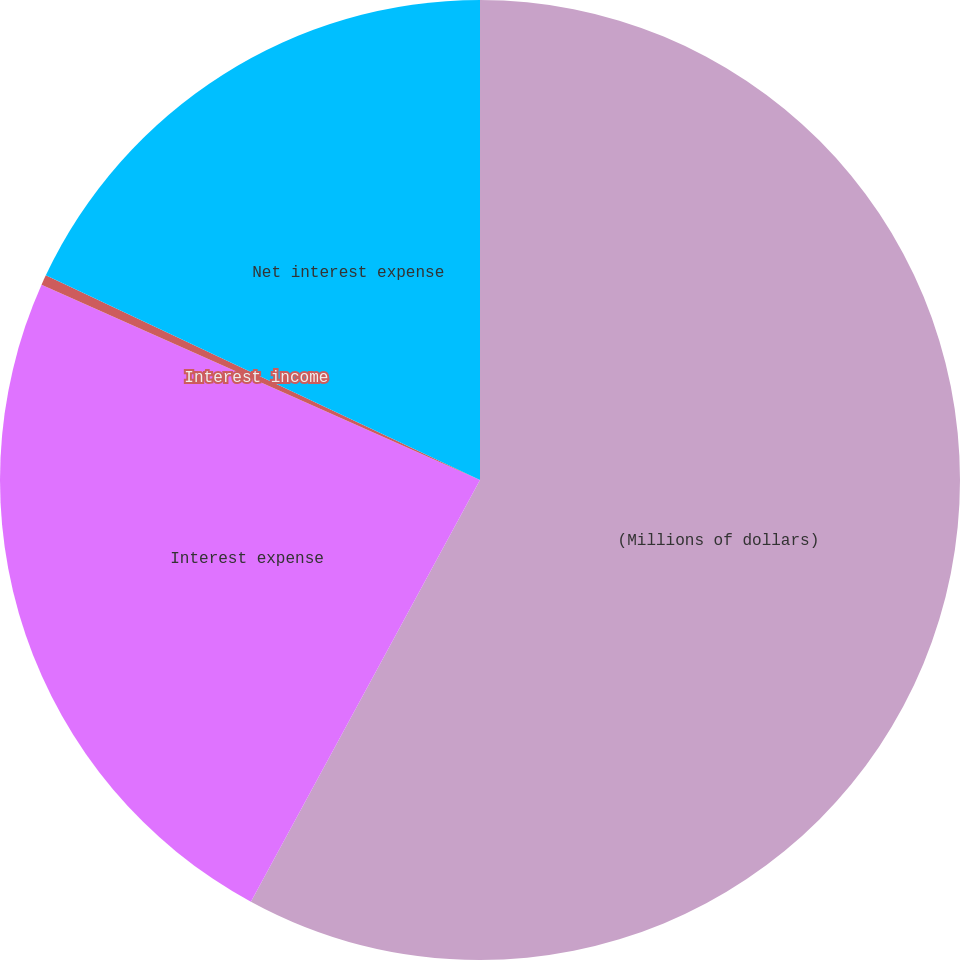Convert chart to OTSL. <chart><loc_0><loc_0><loc_500><loc_500><pie_chart><fcel>(Millions of dollars)<fcel>Interest expense<fcel>Interest income<fcel>Net interest expense<nl><fcel>57.92%<fcel>23.75%<fcel>0.34%<fcel>17.99%<nl></chart> 